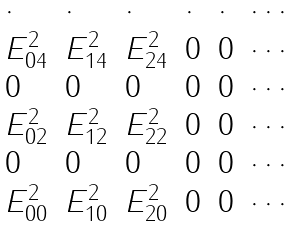Convert formula to latex. <formula><loc_0><loc_0><loc_500><loc_500>\begin{array} { l l l l l l l } \cdot & \cdot & \cdot & \cdot & \cdot & \cdots \\ E _ { 0 4 } ^ { 2 } & E _ { 1 4 } ^ { 2 } & E _ { 2 4 } ^ { 2 } & 0 & 0 & \cdots \\ 0 & 0 & 0 & 0 & 0 & \cdots \\ E _ { 0 2 } ^ { 2 } & E _ { 1 2 } ^ { 2 } & E _ { 2 2 } ^ { 2 } & 0 & 0 & \cdots \\ 0 & 0 & 0 & 0 & 0 & \cdots \\ E _ { 0 0 } ^ { 2 } & E _ { 1 0 } ^ { 2 } & E _ { 2 0 } ^ { 2 } & 0 & 0 & \cdots \\ \end{array}</formula> 